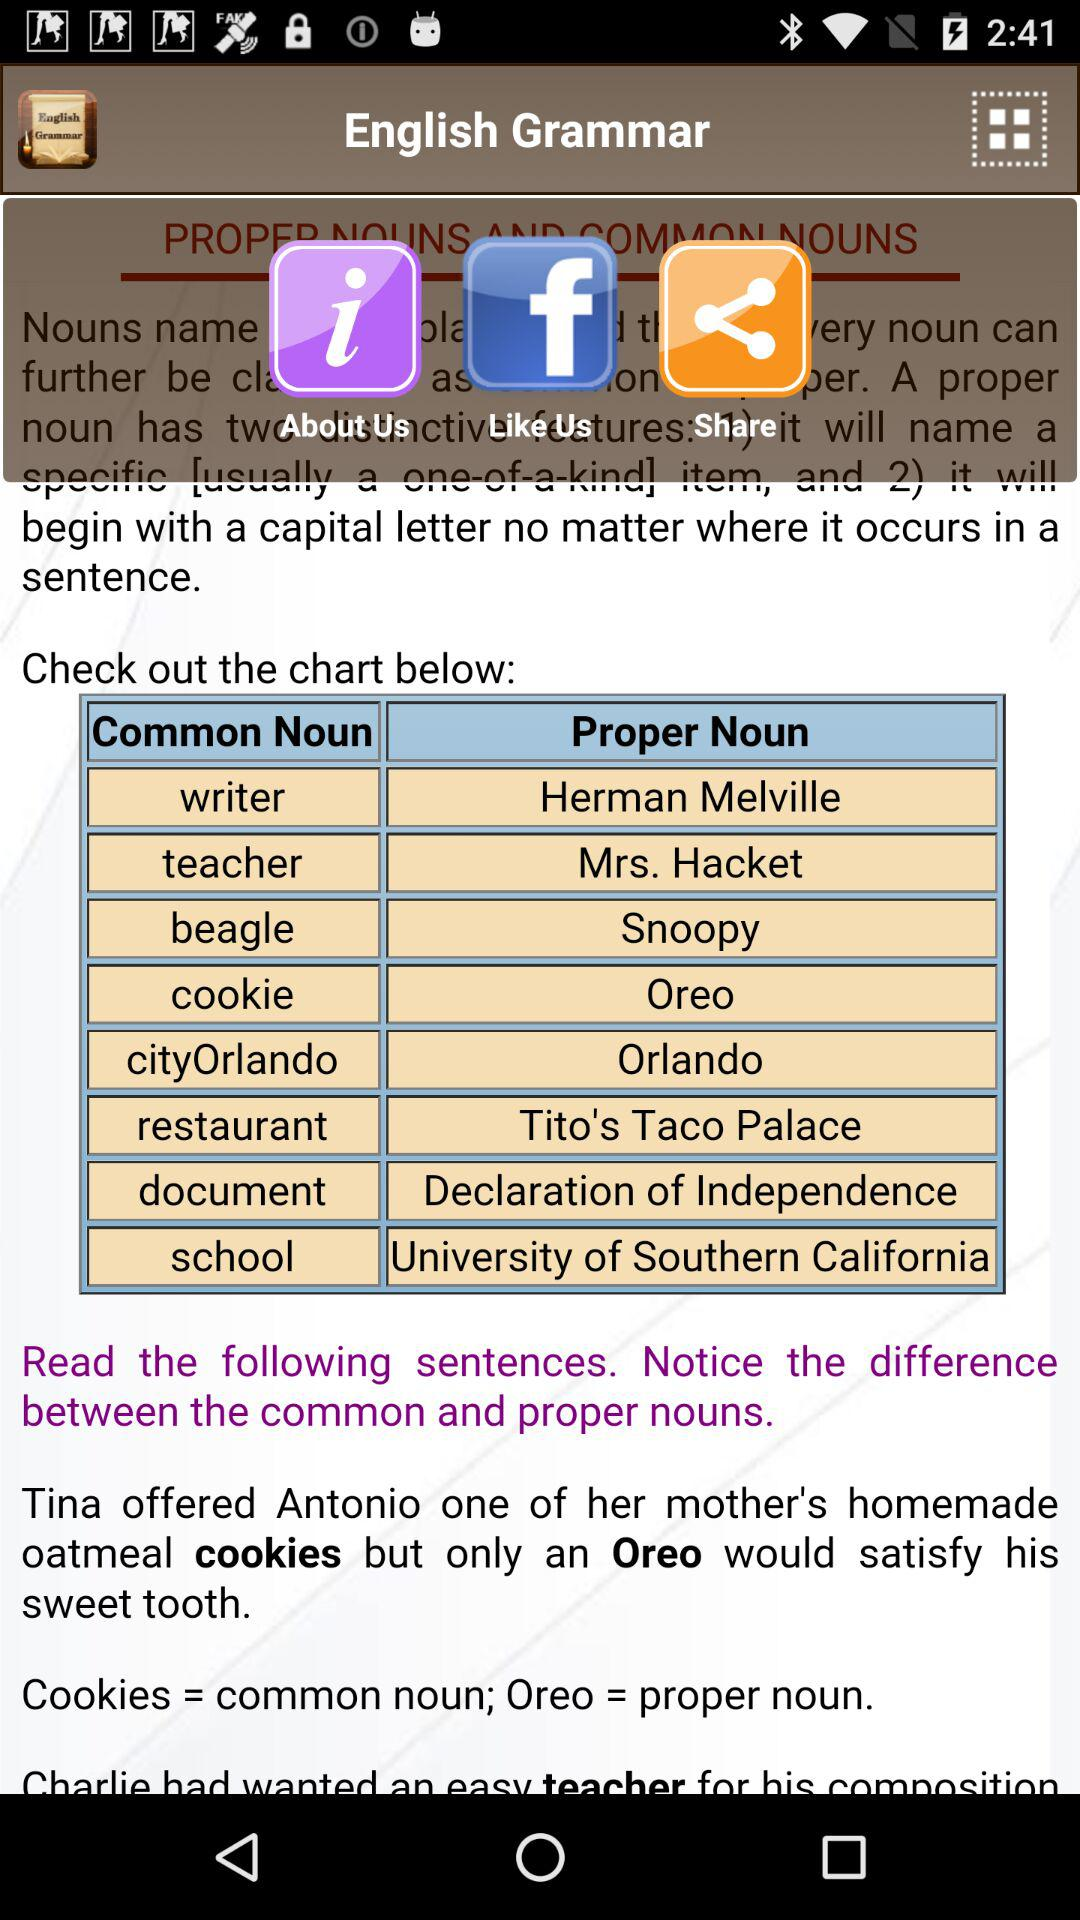What is the example in the common noun table? The examples in the common noun table are "writer", "teacher", "beagle", "cookie", "cityOrlando", "restaurant", "document" and "school". 